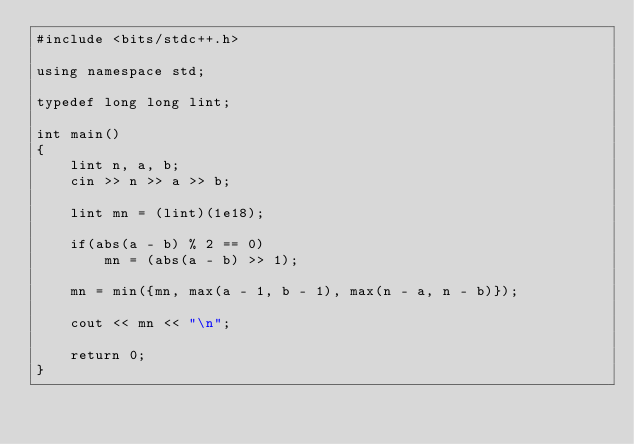<code> <loc_0><loc_0><loc_500><loc_500><_C++_>#include <bits/stdc++.h>

using namespace std;

typedef long long lint;

int main()
{
    lint n, a, b;
    cin >> n >> a >> b;

    lint mn = (lint)(1e18);

    if(abs(a - b) % 2 == 0)
        mn = (abs(a - b) >> 1);

    mn = min({mn, max(a - 1, b - 1), max(n - a, n - b)});

    cout << mn << "\n";

    return 0;
}
</code> 